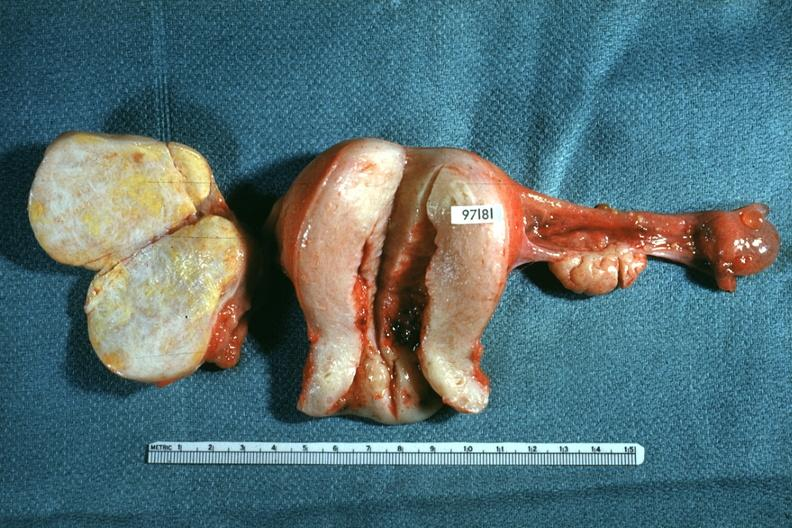what is present?
Answer the question using a single word or phrase. Female reproductive 